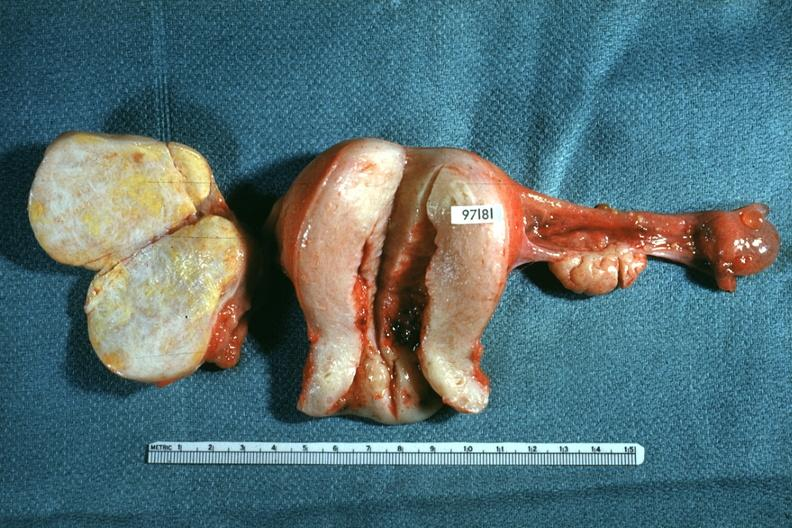what is present?
Answer the question using a single word or phrase. Female reproductive 